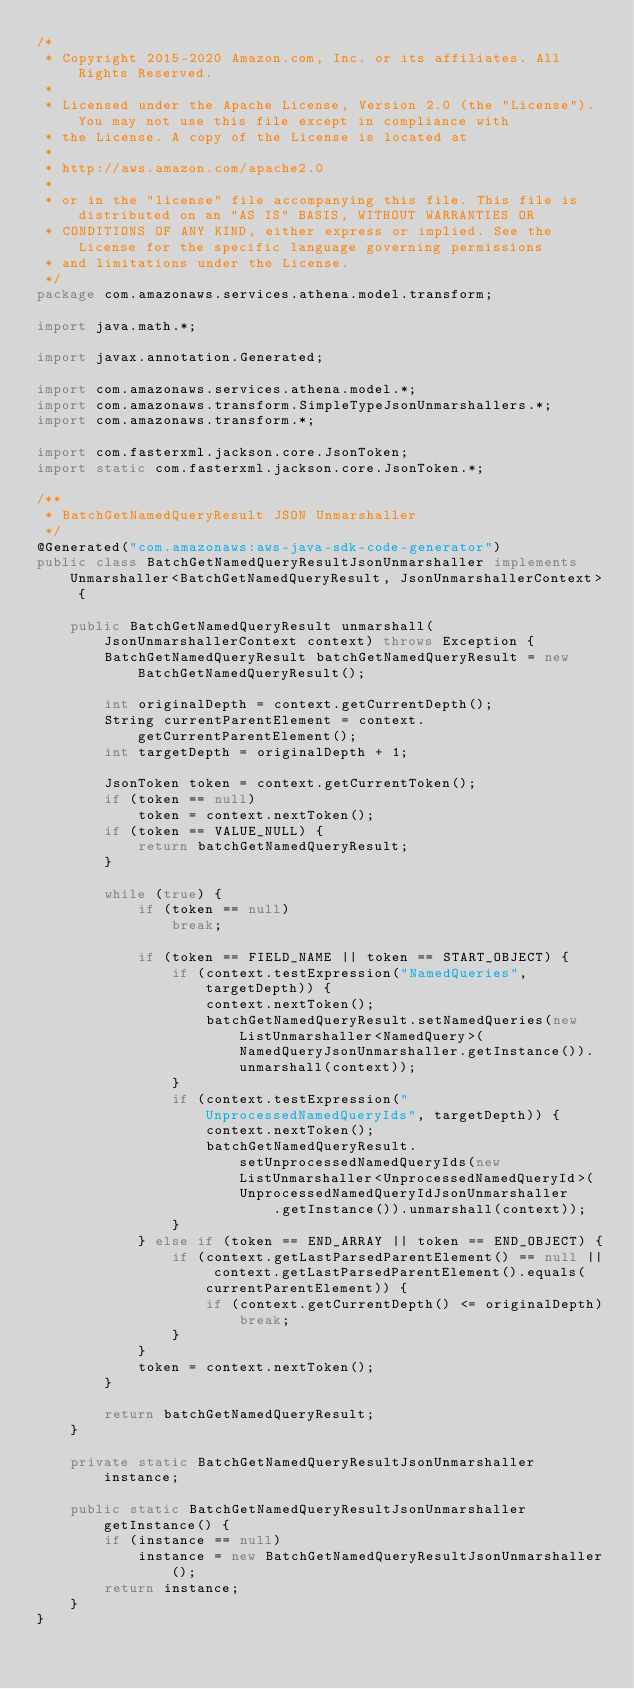Convert code to text. <code><loc_0><loc_0><loc_500><loc_500><_Java_>/*
 * Copyright 2015-2020 Amazon.com, Inc. or its affiliates. All Rights Reserved.
 * 
 * Licensed under the Apache License, Version 2.0 (the "License"). You may not use this file except in compliance with
 * the License. A copy of the License is located at
 * 
 * http://aws.amazon.com/apache2.0
 * 
 * or in the "license" file accompanying this file. This file is distributed on an "AS IS" BASIS, WITHOUT WARRANTIES OR
 * CONDITIONS OF ANY KIND, either express or implied. See the License for the specific language governing permissions
 * and limitations under the License.
 */
package com.amazonaws.services.athena.model.transform;

import java.math.*;

import javax.annotation.Generated;

import com.amazonaws.services.athena.model.*;
import com.amazonaws.transform.SimpleTypeJsonUnmarshallers.*;
import com.amazonaws.transform.*;

import com.fasterxml.jackson.core.JsonToken;
import static com.fasterxml.jackson.core.JsonToken.*;

/**
 * BatchGetNamedQueryResult JSON Unmarshaller
 */
@Generated("com.amazonaws:aws-java-sdk-code-generator")
public class BatchGetNamedQueryResultJsonUnmarshaller implements Unmarshaller<BatchGetNamedQueryResult, JsonUnmarshallerContext> {

    public BatchGetNamedQueryResult unmarshall(JsonUnmarshallerContext context) throws Exception {
        BatchGetNamedQueryResult batchGetNamedQueryResult = new BatchGetNamedQueryResult();

        int originalDepth = context.getCurrentDepth();
        String currentParentElement = context.getCurrentParentElement();
        int targetDepth = originalDepth + 1;

        JsonToken token = context.getCurrentToken();
        if (token == null)
            token = context.nextToken();
        if (token == VALUE_NULL) {
            return batchGetNamedQueryResult;
        }

        while (true) {
            if (token == null)
                break;

            if (token == FIELD_NAME || token == START_OBJECT) {
                if (context.testExpression("NamedQueries", targetDepth)) {
                    context.nextToken();
                    batchGetNamedQueryResult.setNamedQueries(new ListUnmarshaller<NamedQuery>(NamedQueryJsonUnmarshaller.getInstance()).unmarshall(context));
                }
                if (context.testExpression("UnprocessedNamedQueryIds", targetDepth)) {
                    context.nextToken();
                    batchGetNamedQueryResult.setUnprocessedNamedQueryIds(new ListUnmarshaller<UnprocessedNamedQueryId>(UnprocessedNamedQueryIdJsonUnmarshaller
                            .getInstance()).unmarshall(context));
                }
            } else if (token == END_ARRAY || token == END_OBJECT) {
                if (context.getLastParsedParentElement() == null || context.getLastParsedParentElement().equals(currentParentElement)) {
                    if (context.getCurrentDepth() <= originalDepth)
                        break;
                }
            }
            token = context.nextToken();
        }

        return batchGetNamedQueryResult;
    }

    private static BatchGetNamedQueryResultJsonUnmarshaller instance;

    public static BatchGetNamedQueryResultJsonUnmarshaller getInstance() {
        if (instance == null)
            instance = new BatchGetNamedQueryResultJsonUnmarshaller();
        return instance;
    }
}
</code> 